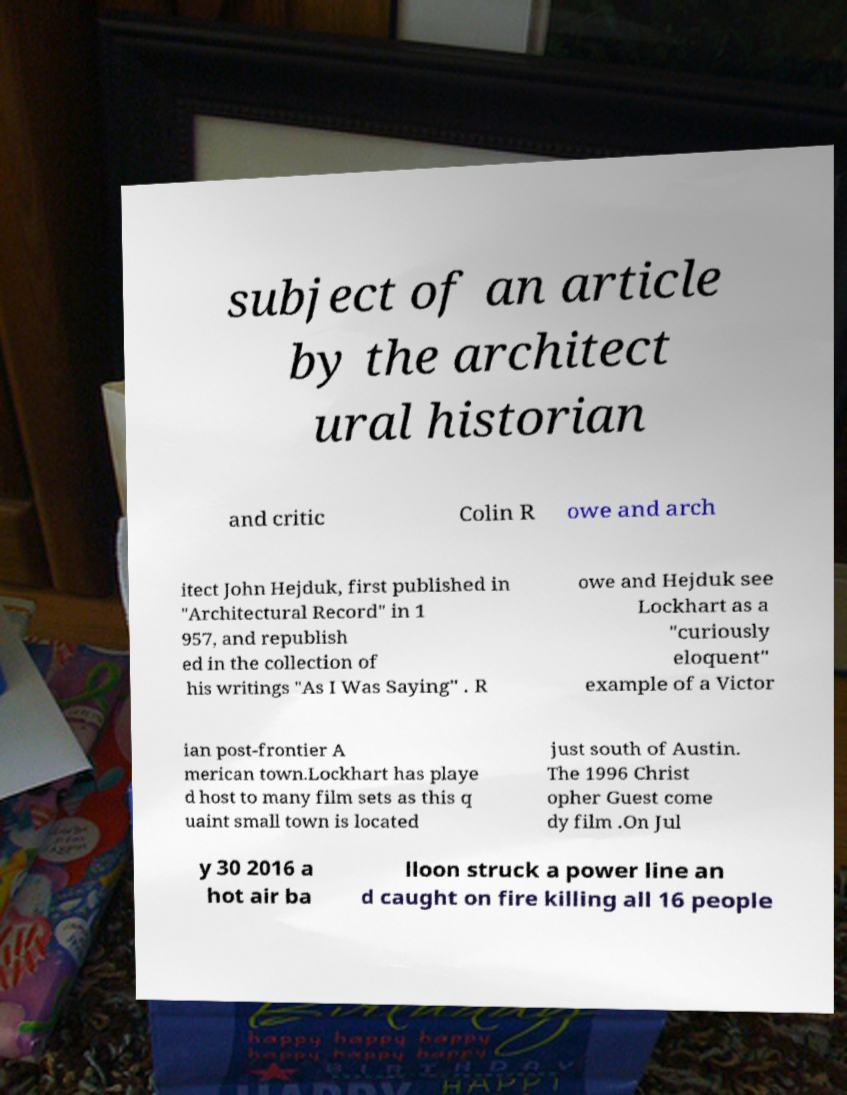I need the written content from this picture converted into text. Can you do that? subject of an article by the architect ural historian and critic Colin R owe and arch itect John Hejduk, first published in "Architectural Record" in 1 957, and republish ed in the collection of his writings "As I Was Saying" . R owe and Hejduk see Lockhart as a "curiously eloquent" example of a Victor ian post-frontier A merican town.Lockhart has playe d host to many film sets as this q uaint small town is located just south of Austin. The 1996 Christ opher Guest come dy film .On Jul y 30 2016 a hot air ba lloon struck a power line an d caught on fire killing all 16 people 